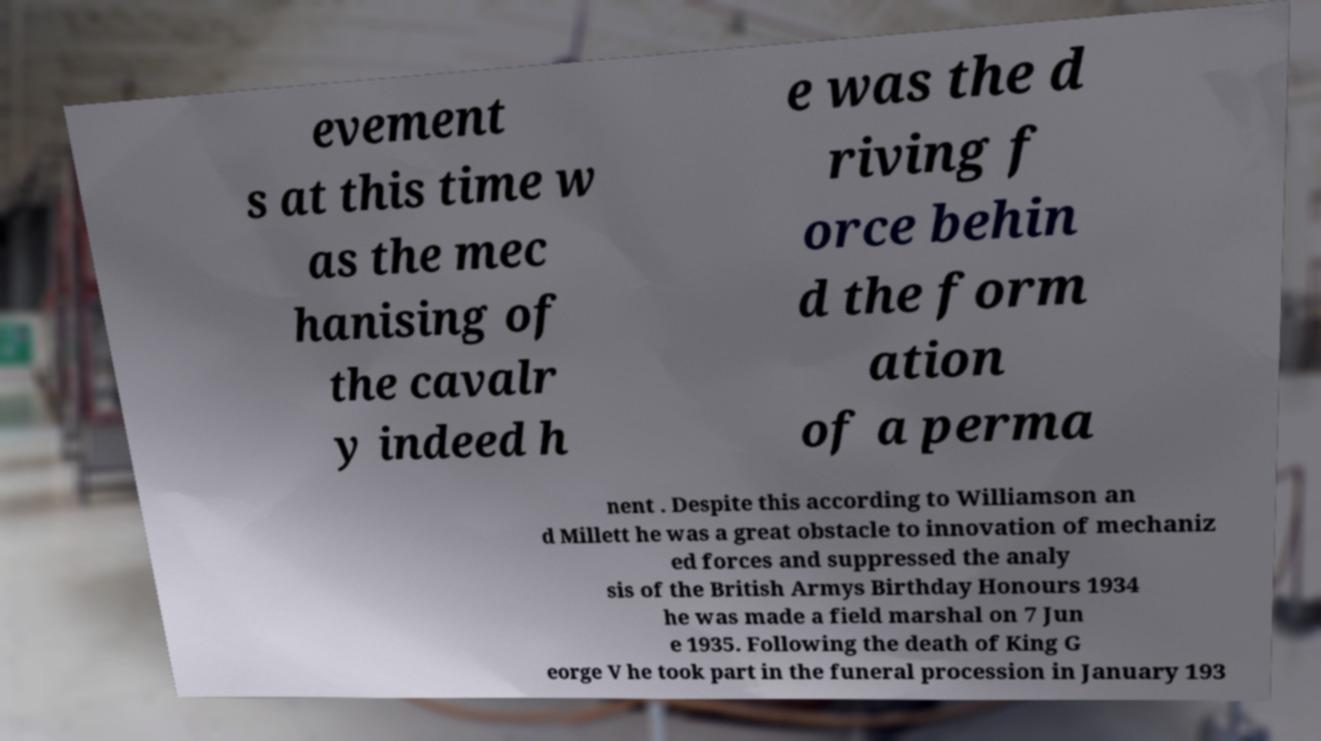Can you accurately transcribe the text from the provided image for me? evement s at this time w as the mec hanising of the cavalr y indeed h e was the d riving f orce behin d the form ation of a perma nent . Despite this according to Williamson an d Millett he was a great obstacle to innovation of mechaniz ed forces and suppressed the analy sis of the British Armys Birthday Honours 1934 he was made a field marshal on 7 Jun e 1935. Following the death of King G eorge V he took part in the funeral procession in January 193 